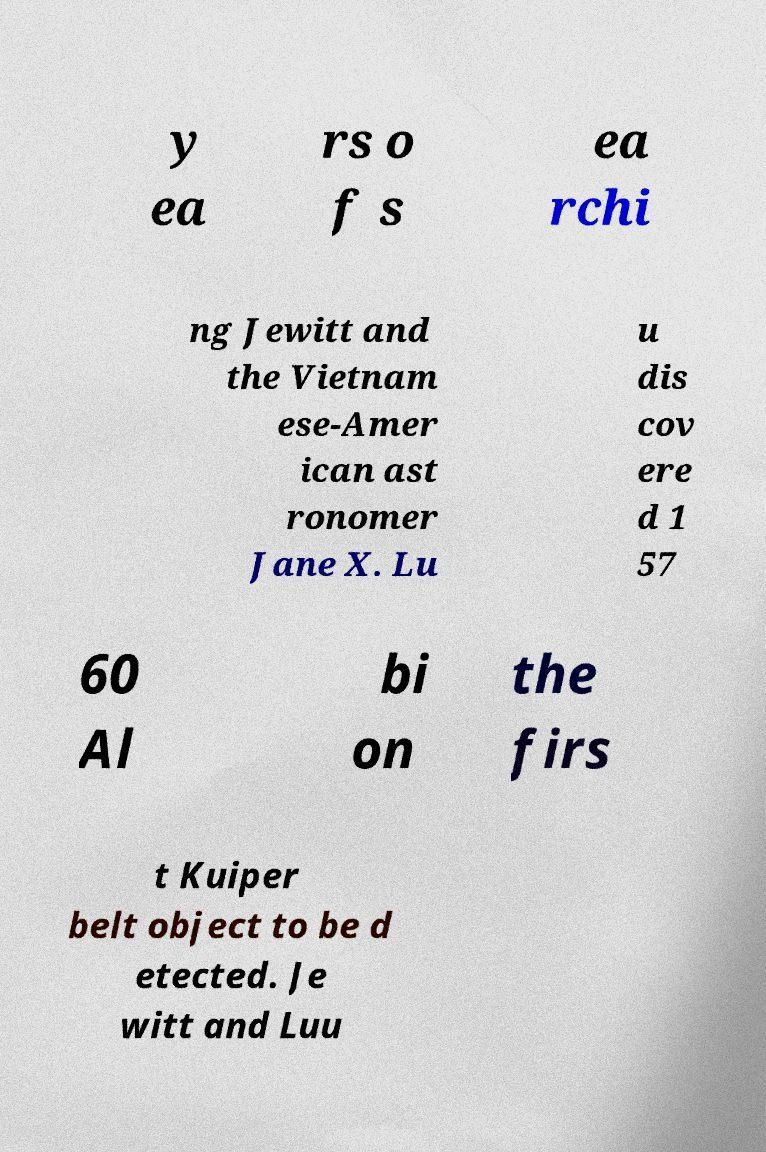For documentation purposes, I need the text within this image transcribed. Could you provide that? y ea rs o f s ea rchi ng Jewitt and the Vietnam ese-Amer ican ast ronomer Jane X. Lu u dis cov ere d 1 57 60 Al bi on the firs t Kuiper belt object to be d etected. Je witt and Luu 